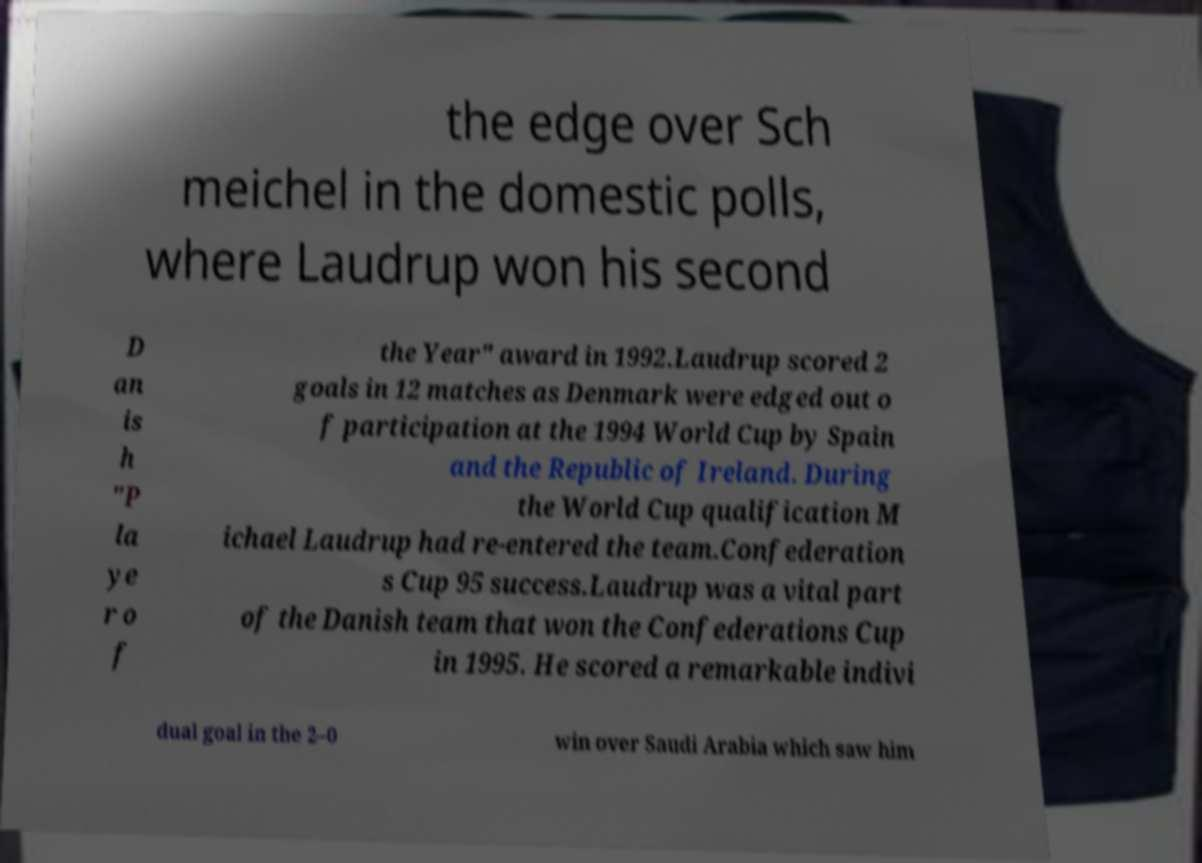Can you read and provide the text displayed in the image?This photo seems to have some interesting text. Can you extract and type it out for me? the edge over Sch meichel in the domestic polls, where Laudrup won his second D an is h "P la ye r o f the Year" award in 1992.Laudrup scored 2 goals in 12 matches as Denmark were edged out o f participation at the 1994 World Cup by Spain and the Republic of Ireland. During the World Cup qualification M ichael Laudrup had re-entered the team.Confederation s Cup 95 success.Laudrup was a vital part of the Danish team that won the Confederations Cup in 1995. He scored a remarkable indivi dual goal in the 2–0 win over Saudi Arabia which saw him 